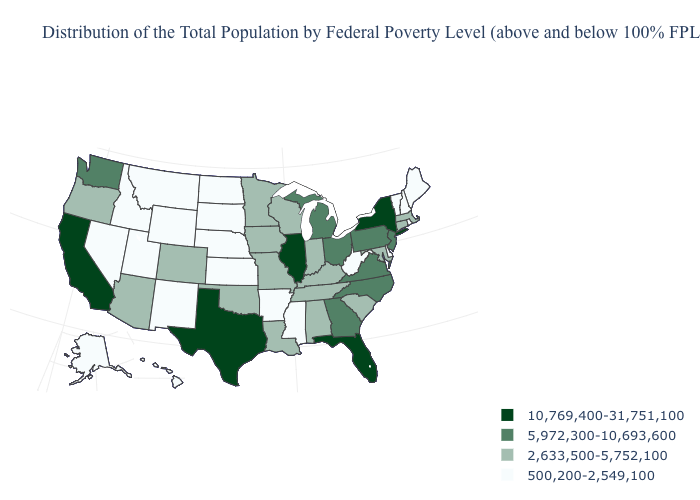How many symbols are there in the legend?
Answer briefly. 4. How many symbols are there in the legend?
Quick response, please. 4. What is the value of Kansas?
Give a very brief answer. 500,200-2,549,100. What is the highest value in states that border Louisiana?
Answer briefly. 10,769,400-31,751,100. Which states hav the highest value in the West?
Short answer required. California. Which states hav the highest value in the MidWest?
Quick response, please. Illinois. What is the value of South Dakota?
Write a very short answer. 500,200-2,549,100. Name the states that have a value in the range 10,769,400-31,751,100?
Concise answer only. California, Florida, Illinois, New York, Texas. Does New Mexico have the lowest value in the USA?
Give a very brief answer. Yes. Does Wyoming have the highest value in the West?
Concise answer only. No. What is the lowest value in states that border Nebraska?
Give a very brief answer. 500,200-2,549,100. Which states have the highest value in the USA?
Give a very brief answer. California, Florida, Illinois, New York, Texas. Does Hawaii have a lower value than New Mexico?
Be succinct. No. Which states have the lowest value in the West?
Be succinct. Alaska, Hawaii, Idaho, Montana, Nevada, New Mexico, Utah, Wyoming. What is the value of New Mexico?
Write a very short answer. 500,200-2,549,100. 